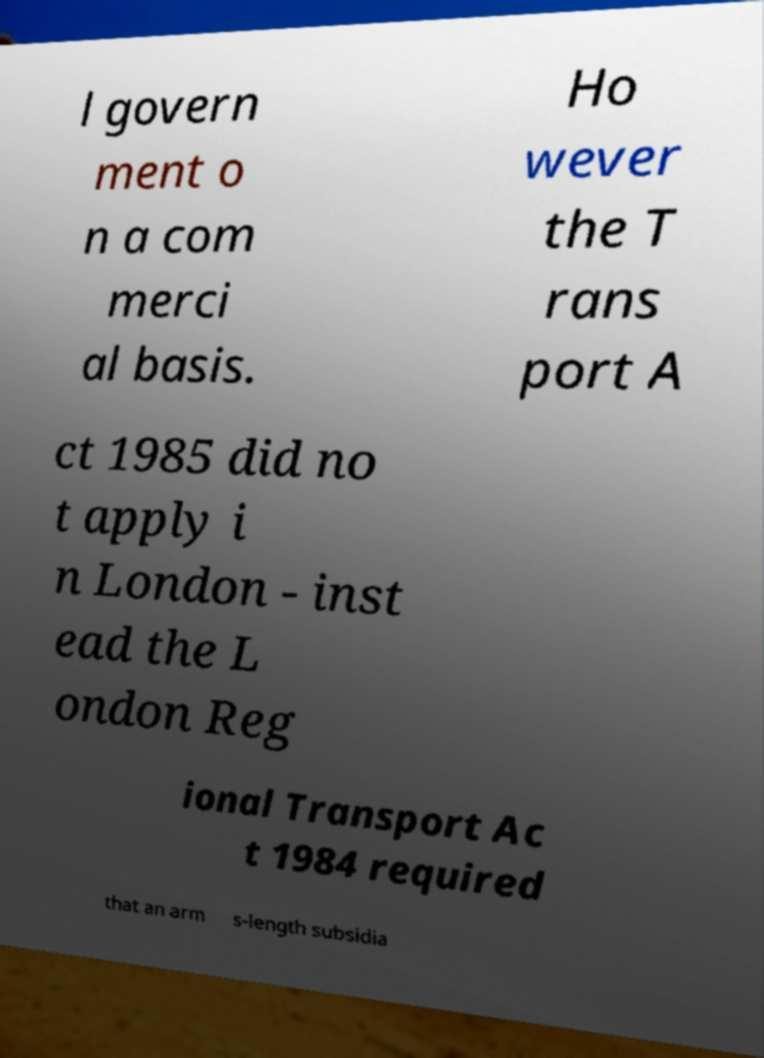There's text embedded in this image that I need extracted. Can you transcribe it verbatim? l govern ment o n a com merci al basis. Ho wever the T rans port A ct 1985 did no t apply i n London - inst ead the L ondon Reg ional Transport Ac t 1984 required that an arm s-length subsidia 